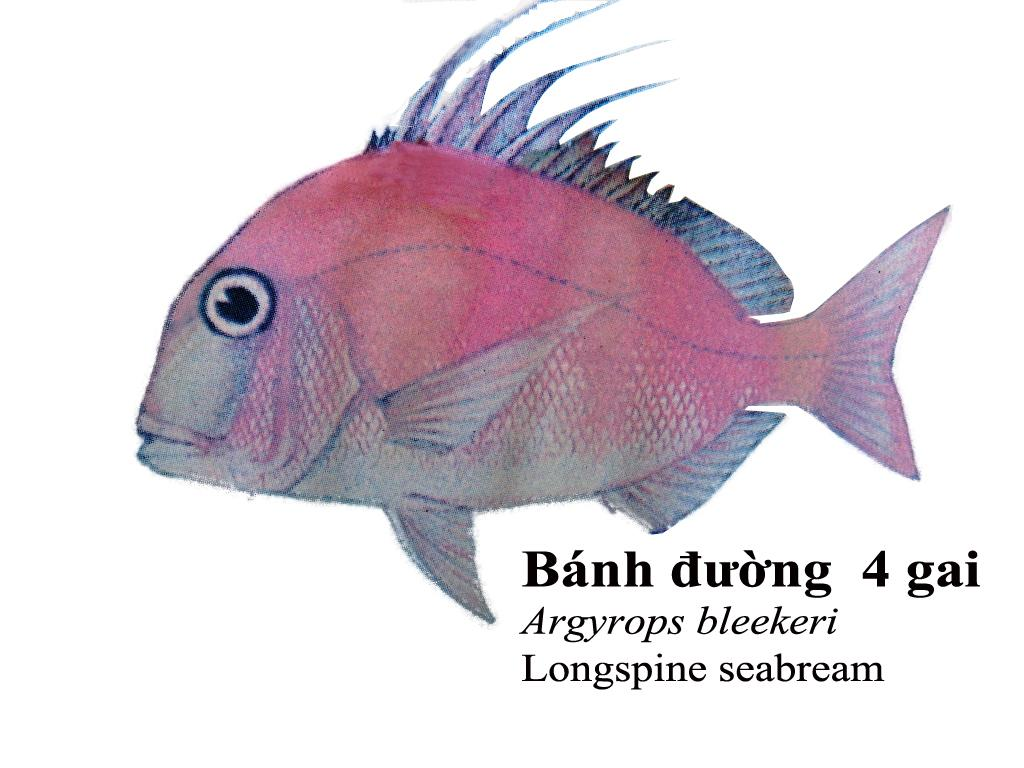What type of artwork is depicted in the image? The image is a painting. What is the main subject of the painting? There is a fish in the center of the painting. Is there any text included in the painting? Yes, there is text at the bottom of the painting. What type of sound does the fish make in the painting? There is no sound depicted in the painting, as it is a visual medium. 